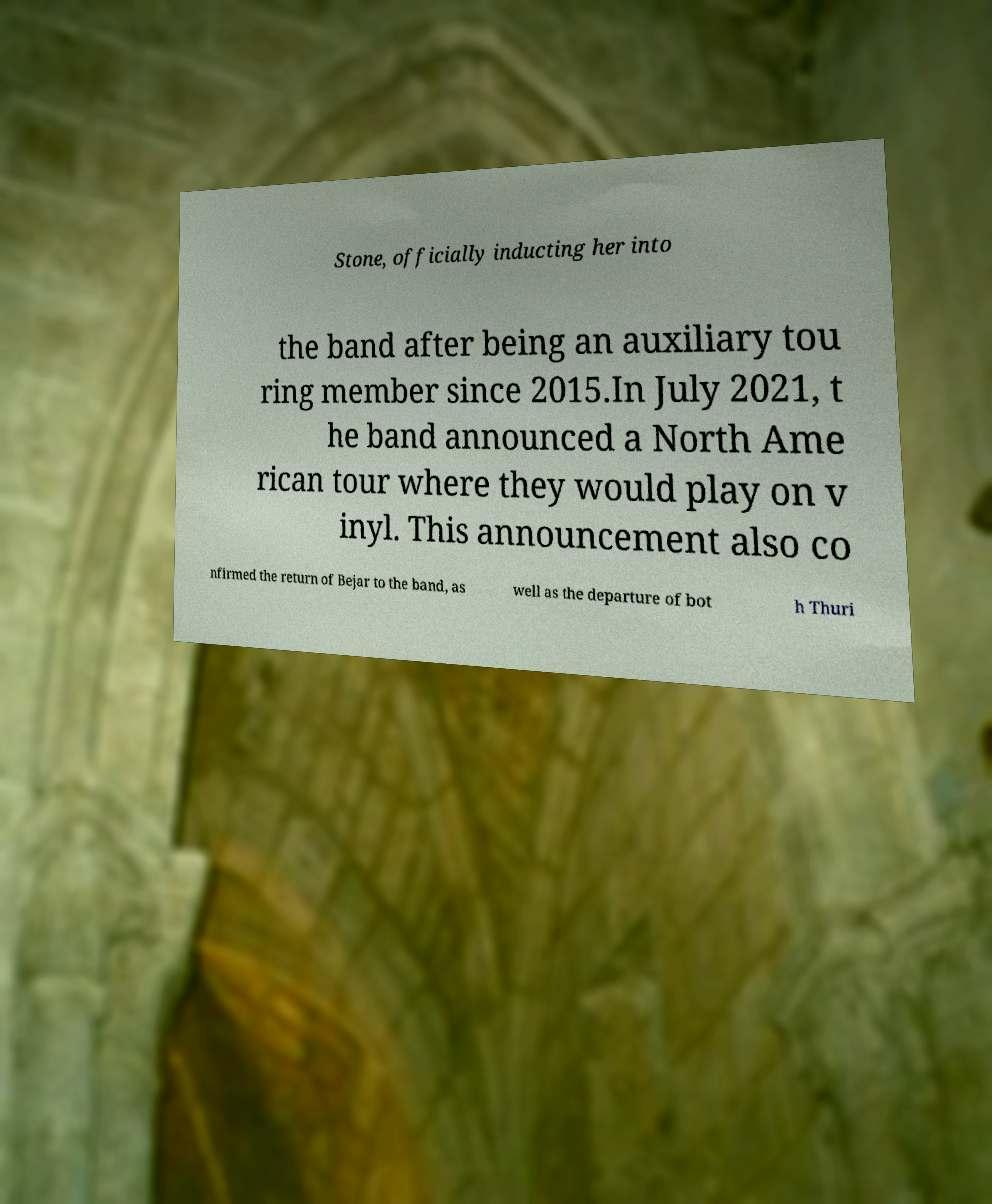For documentation purposes, I need the text within this image transcribed. Could you provide that? Stone, officially inducting her into the band after being an auxiliary tou ring member since 2015.In July 2021, t he band announced a North Ame rican tour where they would play on v inyl. This announcement also co nfirmed the return of Bejar to the band, as well as the departure of bot h Thuri 